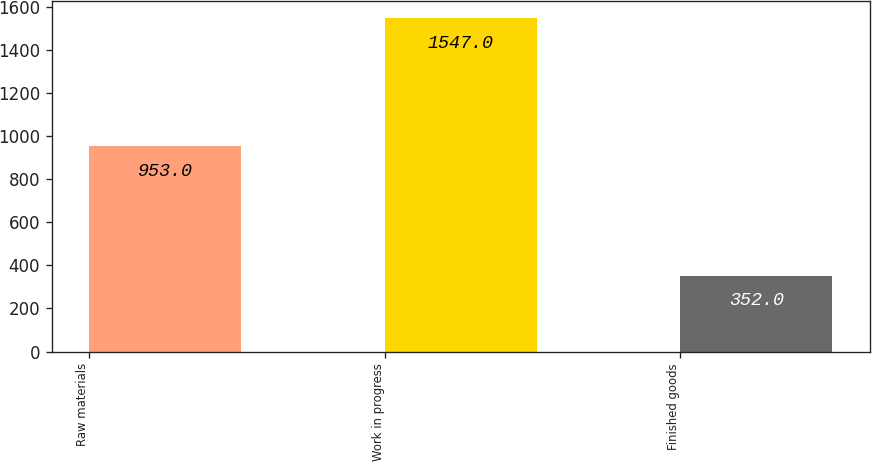<chart> <loc_0><loc_0><loc_500><loc_500><bar_chart><fcel>Raw materials<fcel>Work in progress<fcel>Finished goods<nl><fcel>953<fcel>1547<fcel>352<nl></chart> 